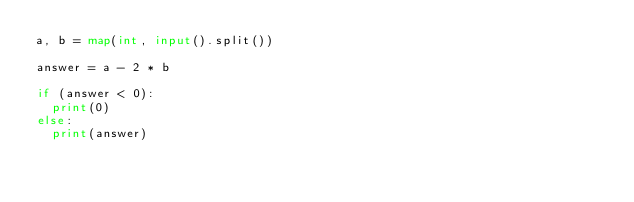Convert code to text. <code><loc_0><loc_0><loc_500><loc_500><_Python_>a, b = map(int, input().split())

answer = a - 2 * b

if (answer < 0):
  print(0)
else:
  print(answer)</code> 